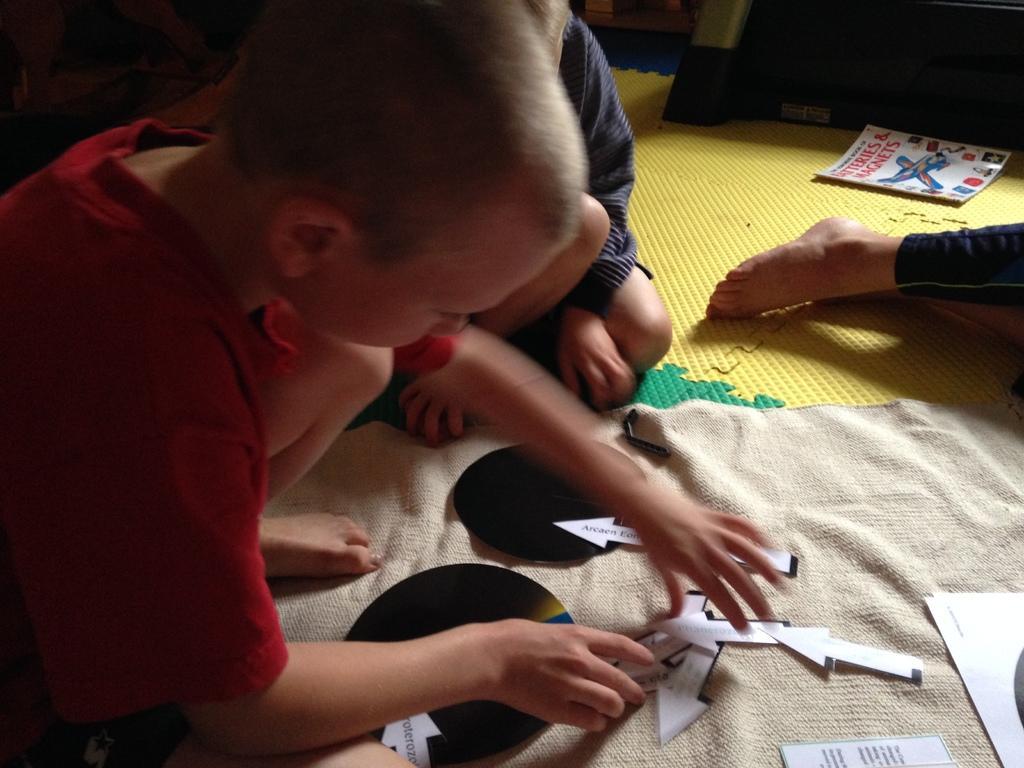Please provide a concise description of this image. On the left side of the image there is a kid sitting on the cloth. On the cloth there are arrow shaped papers and some other papers. There are black color things on the cloth. Behind the boy there is a kid sitting on the floor. And we can see the legs of a person. On the floor there is mat. There is a paper with images on it. 